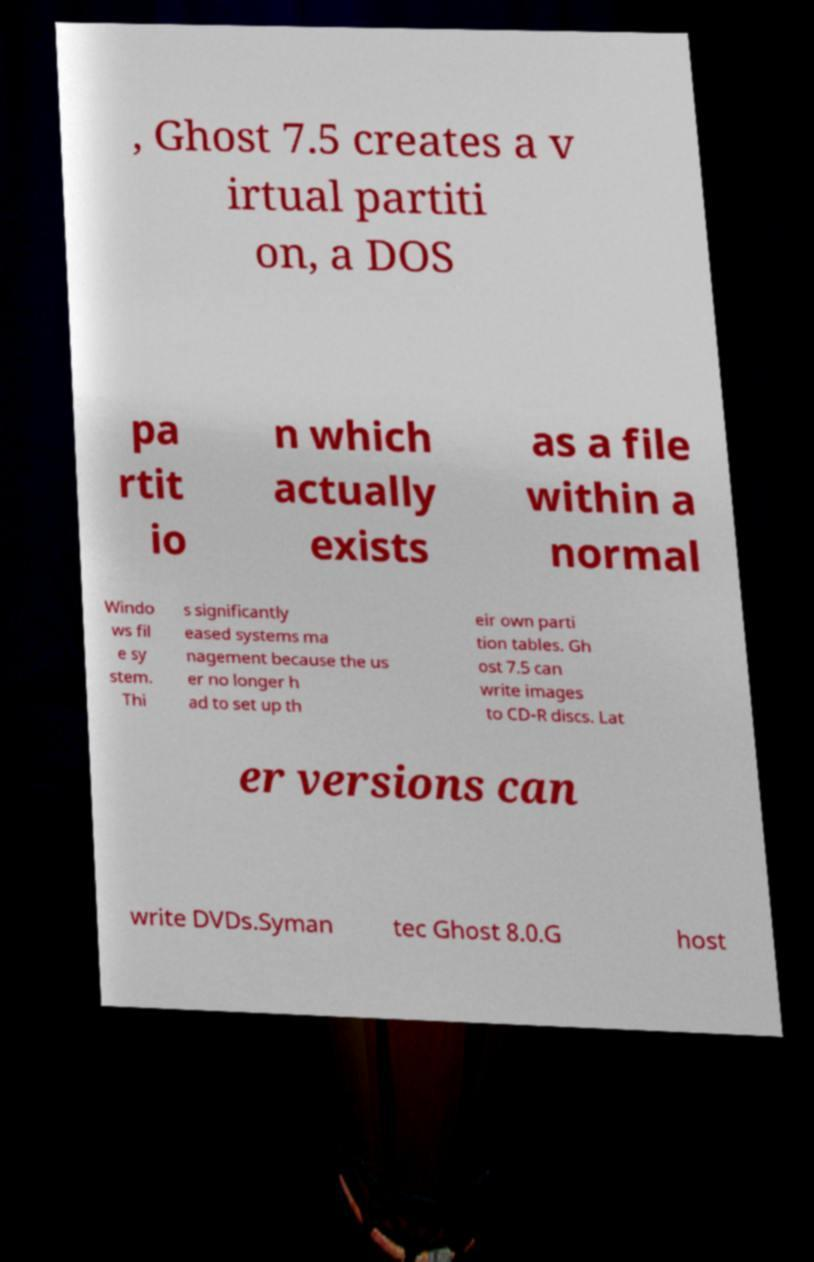Could you assist in decoding the text presented in this image and type it out clearly? , Ghost 7.5 creates a v irtual partiti on, a DOS pa rtit io n which actually exists as a file within a normal Windo ws fil e sy stem. Thi s significantly eased systems ma nagement because the us er no longer h ad to set up th eir own parti tion tables. Gh ost 7.5 can write images to CD-R discs. Lat er versions can write DVDs.Syman tec Ghost 8.0.G host 